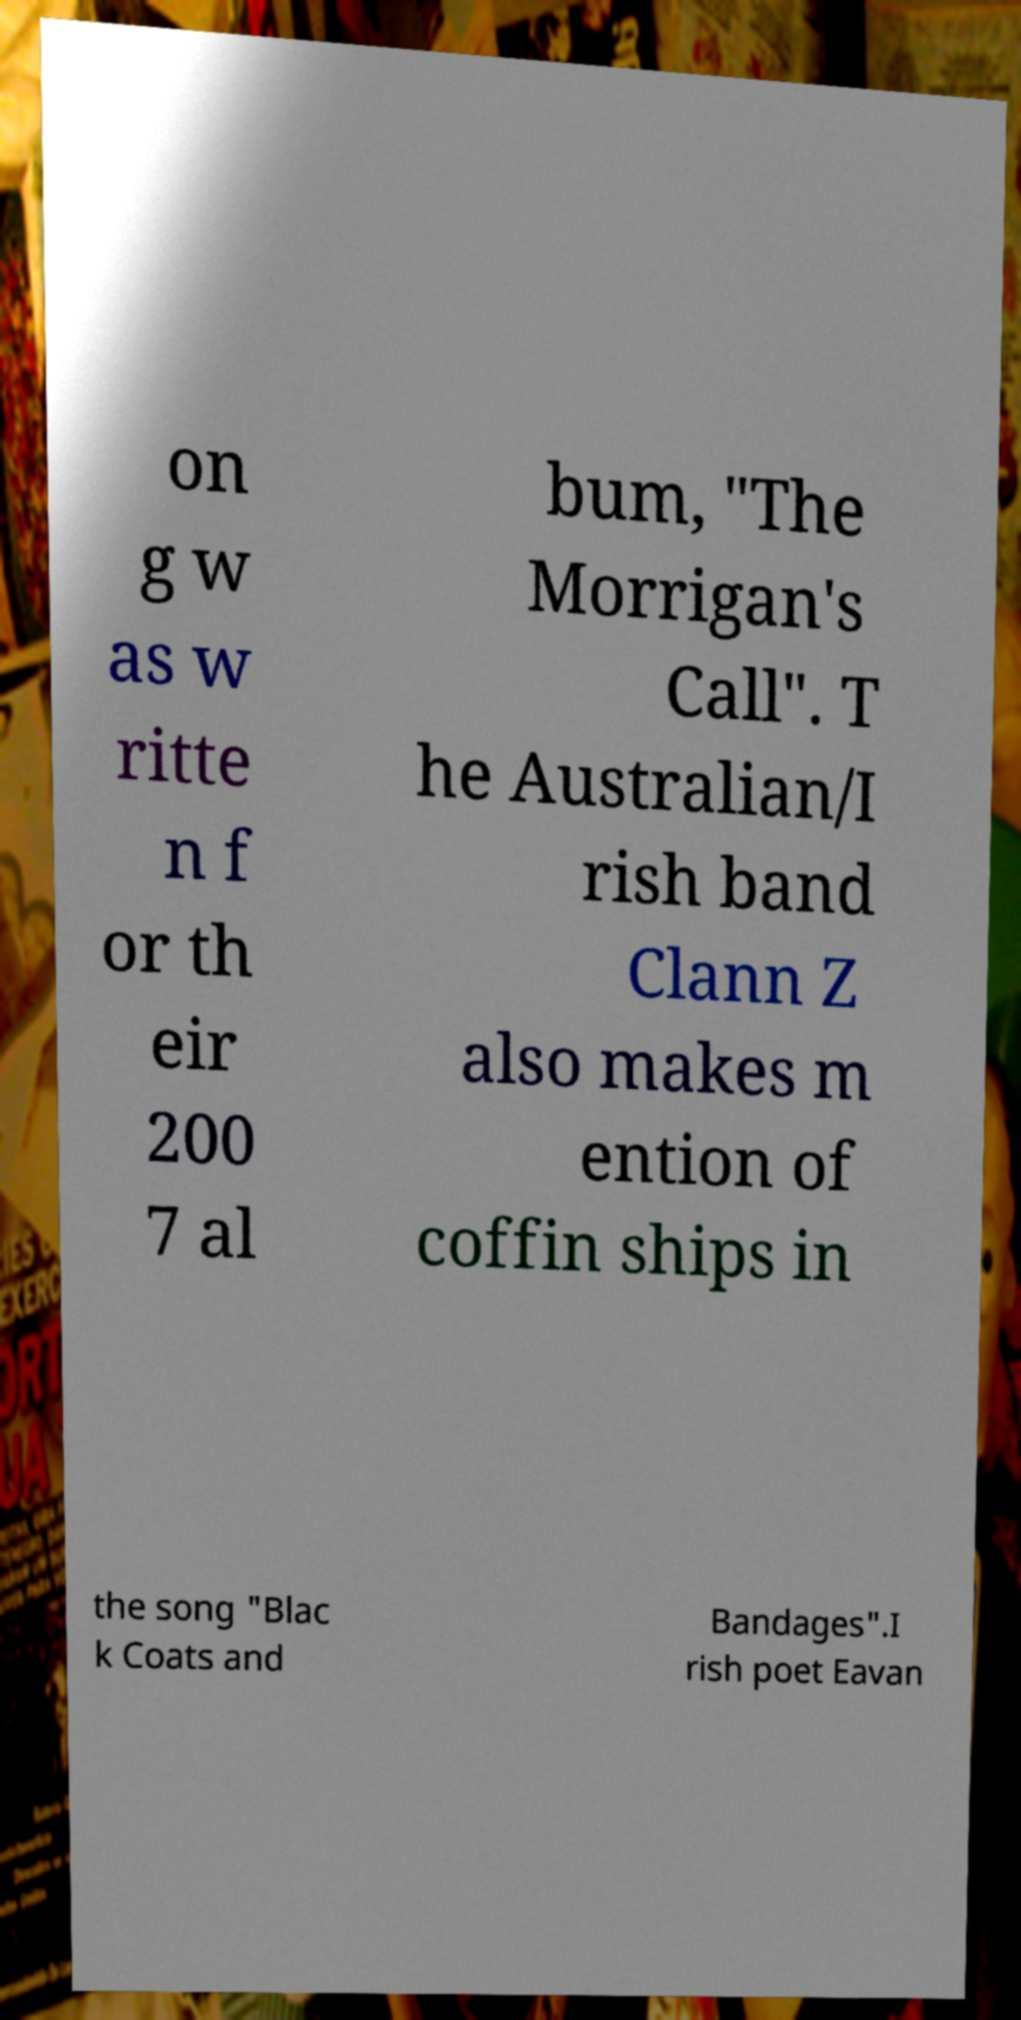I need the written content from this picture converted into text. Can you do that? on g w as w ritte n f or th eir 200 7 al bum, "The Morrigan's Call". T he Australian/I rish band Clann Z also makes m ention of coffin ships in the song "Blac k Coats and Bandages".I rish poet Eavan 